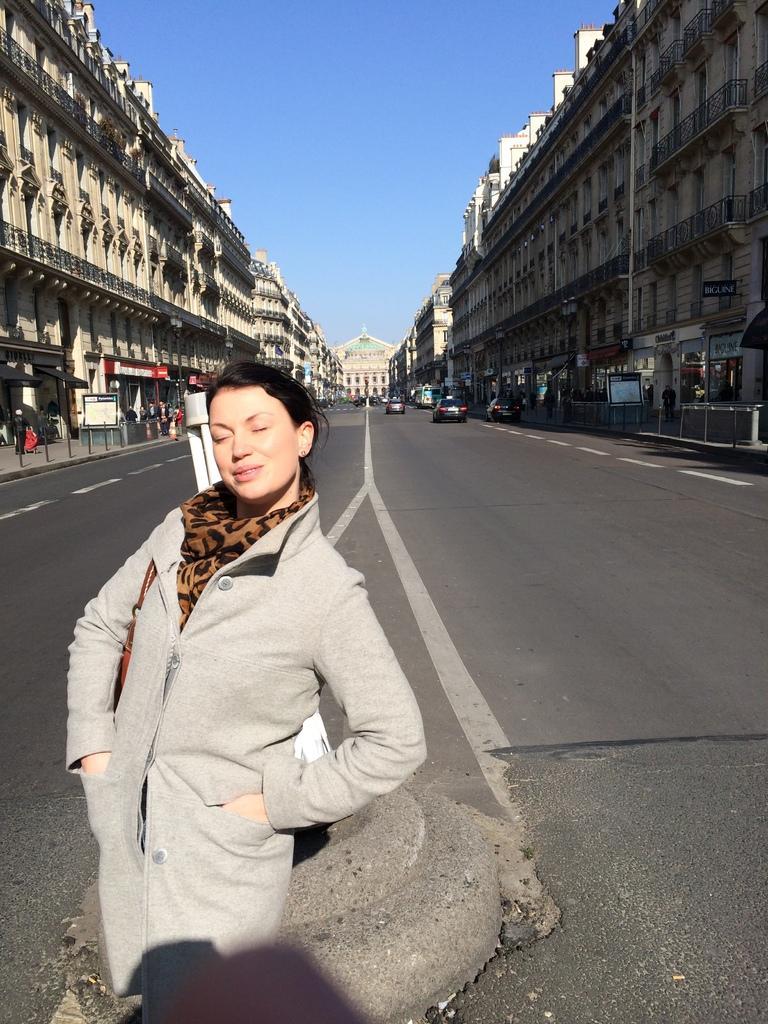How would you summarize this image in a sentence or two? In this image in the front there is a woman standing and smiling. In the background there are buildings, there are poles and there are cars moving on the road. 